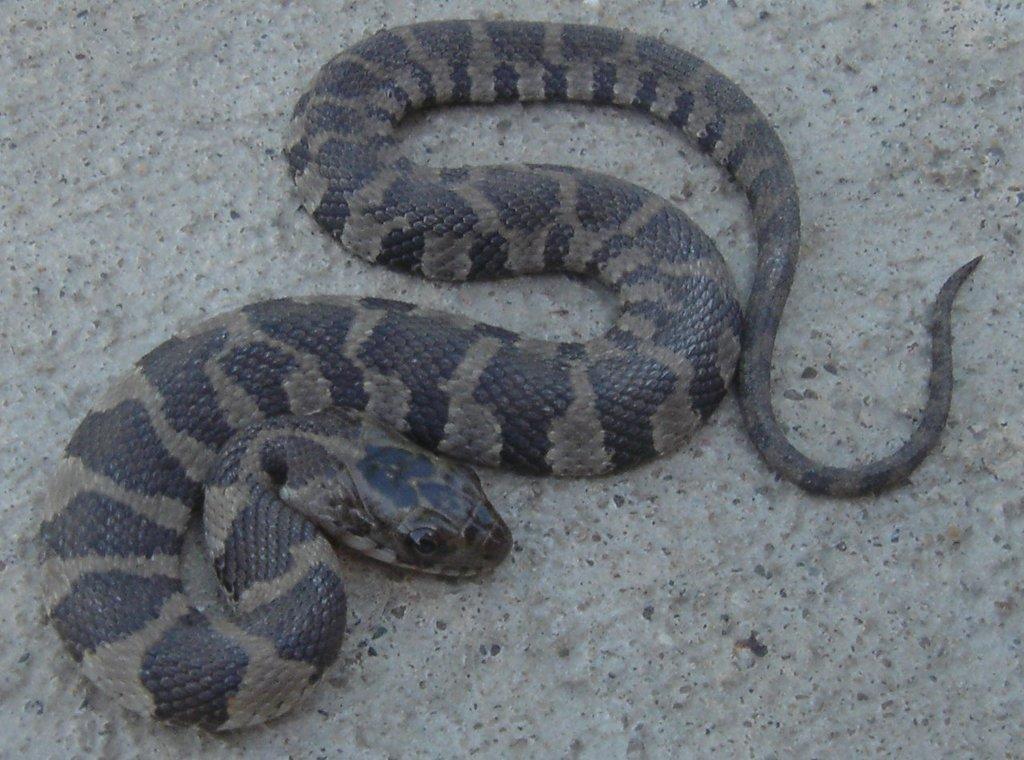What type of animal is in the image? There is a snake in the image. Where is the snake located in the image? The snake is on the ground. What type of pocket can be seen on the snake in the image? There are no pockets on the snake in the image, as snakes do not have clothing or accessories. 